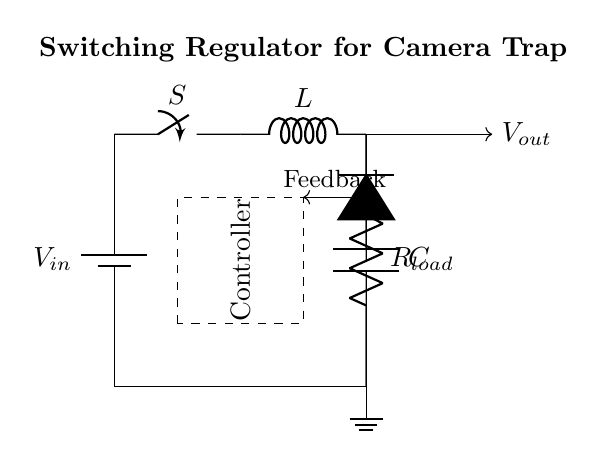What type of switch is used in this circuit? The circuit uses a mechanical switch, labeled as S, represented in the diagram.
Answer: Mechanical switch What is the role of the inductor in this circuit? The inductor, labeled L, stores energy in its magnetic field when current flows through it, which is fundamental for the regulator's operation.
Answer: Energy storage What is the output voltage of the regulator? The circuit diagram does not specify a value for the output voltage, but it indicates that it is connected to the load, represented by R_load.
Answer: Not specified How many capacitors are present in this circuit? There is one capacitor, labeled C, that is used in conjunction with the inductor for smoothing the output voltage.
Answer: One What is the function of the feedback loop in this circuit? The feedback loop, indicated by the arrow pointing back from the output, helps to maintain the desired output voltage by adjusting the switch operation based on the output conditions.
Answer: Voltage regulation What is the main component that ensures efficient power management in this circuit? The controller component, marked by the dashed rectangle, regulates the operation of the switch to manage power efficiently.
Answer: Controller 